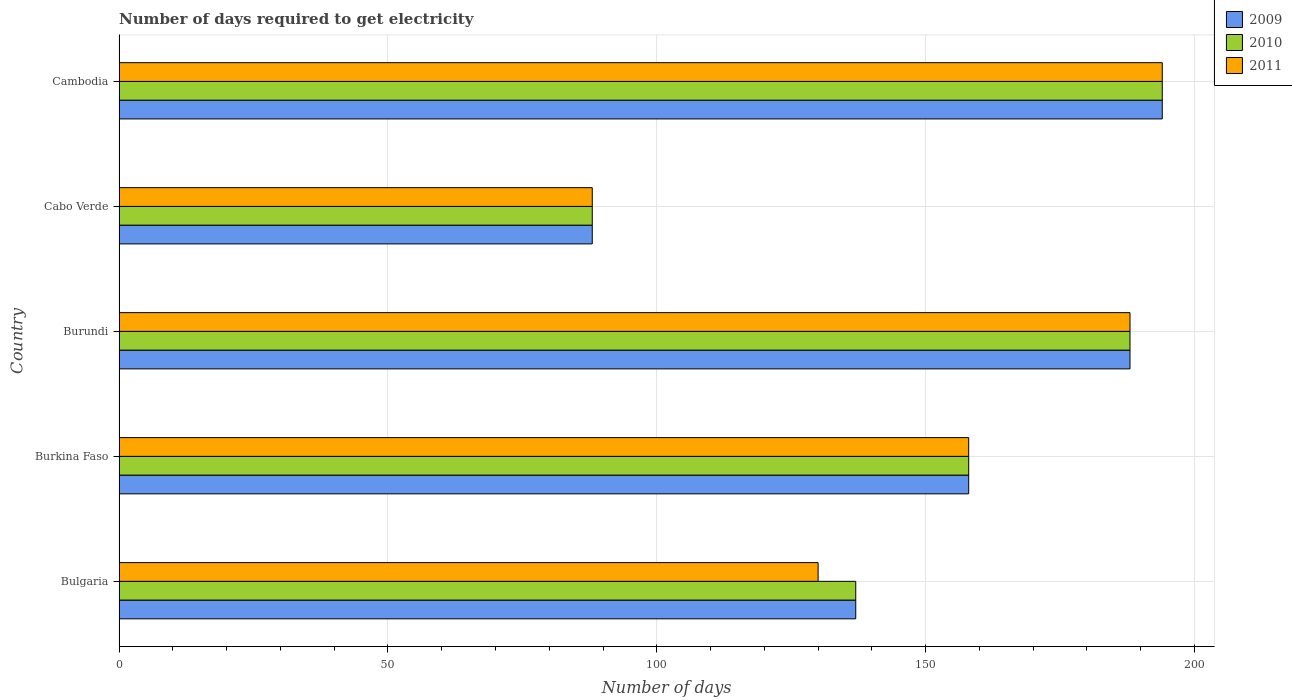How many different coloured bars are there?
Offer a terse response. 3. Are the number of bars per tick equal to the number of legend labels?
Offer a terse response. Yes. Are the number of bars on each tick of the Y-axis equal?
Provide a short and direct response. Yes. How many bars are there on the 3rd tick from the top?
Offer a very short reply. 3. How many bars are there on the 2nd tick from the bottom?
Provide a succinct answer. 3. What is the label of the 3rd group of bars from the top?
Give a very brief answer. Burundi. In how many cases, is the number of bars for a given country not equal to the number of legend labels?
Offer a terse response. 0. What is the number of days required to get electricity in in 2010 in Burkina Faso?
Provide a short and direct response. 158. Across all countries, what is the maximum number of days required to get electricity in in 2011?
Ensure brevity in your answer.  194. Across all countries, what is the minimum number of days required to get electricity in in 2011?
Keep it short and to the point. 88. In which country was the number of days required to get electricity in in 2011 maximum?
Offer a terse response. Cambodia. In which country was the number of days required to get electricity in in 2011 minimum?
Your answer should be compact. Cabo Verde. What is the total number of days required to get electricity in in 2009 in the graph?
Provide a short and direct response. 765. What is the average number of days required to get electricity in in 2010 per country?
Your response must be concise. 153. What is the difference between the number of days required to get electricity in in 2009 and number of days required to get electricity in in 2010 in Bulgaria?
Provide a short and direct response. 0. What is the ratio of the number of days required to get electricity in in 2010 in Burundi to that in Cabo Verde?
Ensure brevity in your answer.  2.14. What is the difference between the highest and the lowest number of days required to get electricity in in 2010?
Offer a very short reply. 106. In how many countries, is the number of days required to get electricity in in 2011 greater than the average number of days required to get electricity in in 2011 taken over all countries?
Your answer should be compact. 3. Is the sum of the number of days required to get electricity in in 2009 in Burkina Faso and Burundi greater than the maximum number of days required to get electricity in in 2011 across all countries?
Your answer should be compact. Yes. Is it the case that in every country, the sum of the number of days required to get electricity in in 2009 and number of days required to get electricity in in 2011 is greater than the number of days required to get electricity in in 2010?
Your answer should be compact. Yes. How many countries are there in the graph?
Make the answer very short. 5. Does the graph contain grids?
Ensure brevity in your answer.  Yes. Where does the legend appear in the graph?
Your answer should be very brief. Top right. How many legend labels are there?
Provide a succinct answer. 3. How are the legend labels stacked?
Ensure brevity in your answer.  Vertical. What is the title of the graph?
Your answer should be compact. Number of days required to get electricity. Does "2009" appear as one of the legend labels in the graph?
Your answer should be very brief. Yes. What is the label or title of the X-axis?
Offer a terse response. Number of days. What is the label or title of the Y-axis?
Give a very brief answer. Country. What is the Number of days of 2009 in Bulgaria?
Give a very brief answer. 137. What is the Number of days of 2010 in Bulgaria?
Provide a succinct answer. 137. What is the Number of days of 2011 in Bulgaria?
Provide a succinct answer. 130. What is the Number of days in 2009 in Burkina Faso?
Make the answer very short. 158. What is the Number of days in 2010 in Burkina Faso?
Your answer should be compact. 158. What is the Number of days in 2011 in Burkina Faso?
Keep it short and to the point. 158. What is the Number of days of 2009 in Burundi?
Provide a short and direct response. 188. What is the Number of days of 2010 in Burundi?
Offer a terse response. 188. What is the Number of days of 2011 in Burundi?
Your answer should be compact. 188. What is the Number of days of 2009 in Cabo Verde?
Your answer should be very brief. 88. What is the Number of days of 2010 in Cabo Verde?
Provide a succinct answer. 88. What is the Number of days in 2011 in Cabo Verde?
Your answer should be compact. 88. What is the Number of days of 2009 in Cambodia?
Your answer should be compact. 194. What is the Number of days in 2010 in Cambodia?
Keep it short and to the point. 194. What is the Number of days in 2011 in Cambodia?
Ensure brevity in your answer.  194. Across all countries, what is the maximum Number of days of 2009?
Make the answer very short. 194. Across all countries, what is the maximum Number of days in 2010?
Your response must be concise. 194. Across all countries, what is the maximum Number of days of 2011?
Offer a terse response. 194. What is the total Number of days of 2009 in the graph?
Your answer should be compact. 765. What is the total Number of days of 2010 in the graph?
Keep it short and to the point. 765. What is the total Number of days of 2011 in the graph?
Ensure brevity in your answer.  758. What is the difference between the Number of days of 2009 in Bulgaria and that in Burundi?
Provide a short and direct response. -51. What is the difference between the Number of days of 2010 in Bulgaria and that in Burundi?
Ensure brevity in your answer.  -51. What is the difference between the Number of days of 2011 in Bulgaria and that in Burundi?
Provide a short and direct response. -58. What is the difference between the Number of days of 2009 in Bulgaria and that in Cabo Verde?
Your answer should be compact. 49. What is the difference between the Number of days of 2009 in Bulgaria and that in Cambodia?
Make the answer very short. -57. What is the difference between the Number of days in 2010 in Bulgaria and that in Cambodia?
Provide a short and direct response. -57. What is the difference between the Number of days of 2011 in Bulgaria and that in Cambodia?
Make the answer very short. -64. What is the difference between the Number of days of 2009 in Burkina Faso and that in Burundi?
Offer a terse response. -30. What is the difference between the Number of days of 2011 in Burkina Faso and that in Cabo Verde?
Give a very brief answer. 70. What is the difference between the Number of days of 2009 in Burkina Faso and that in Cambodia?
Provide a succinct answer. -36. What is the difference between the Number of days in 2010 in Burkina Faso and that in Cambodia?
Give a very brief answer. -36. What is the difference between the Number of days in 2011 in Burkina Faso and that in Cambodia?
Your answer should be very brief. -36. What is the difference between the Number of days in 2010 in Burundi and that in Cabo Verde?
Ensure brevity in your answer.  100. What is the difference between the Number of days in 2010 in Burundi and that in Cambodia?
Your answer should be compact. -6. What is the difference between the Number of days in 2011 in Burundi and that in Cambodia?
Provide a short and direct response. -6. What is the difference between the Number of days of 2009 in Cabo Verde and that in Cambodia?
Your answer should be very brief. -106. What is the difference between the Number of days of 2010 in Cabo Verde and that in Cambodia?
Your answer should be compact. -106. What is the difference between the Number of days of 2011 in Cabo Verde and that in Cambodia?
Keep it short and to the point. -106. What is the difference between the Number of days in 2009 in Bulgaria and the Number of days in 2010 in Burundi?
Keep it short and to the point. -51. What is the difference between the Number of days of 2009 in Bulgaria and the Number of days of 2011 in Burundi?
Ensure brevity in your answer.  -51. What is the difference between the Number of days in 2010 in Bulgaria and the Number of days in 2011 in Burundi?
Your answer should be very brief. -51. What is the difference between the Number of days in 2009 in Bulgaria and the Number of days in 2010 in Cabo Verde?
Your answer should be compact. 49. What is the difference between the Number of days of 2010 in Bulgaria and the Number of days of 2011 in Cabo Verde?
Provide a succinct answer. 49. What is the difference between the Number of days in 2009 in Bulgaria and the Number of days in 2010 in Cambodia?
Offer a terse response. -57. What is the difference between the Number of days in 2009 in Bulgaria and the Number of days in 2011 in Cambodia?
Offer a terse response. -57. What is the difference between the Number of days of 2010 in Bulgaria and the Number of days of 2011 in Cambodia?
Make the answer very short. -57. What is the difference between the Number of days in 2009 in Burkina Faso and the Number of days in 2011 in Burundi?
Your answer should be very brief. -30. What is the difference between the Number of days in 2009 in Burkina Faso and the Number of days in 2011 in Cabo Verde?
Provide a short and direct response. 70. What is the difference between the Number of days of 2009 in Burkina Faso and the Number of days of 2010 in Cambodia?
Give a very brief answer. -36. What is the difference between the Number of days of 2009 in Burkina Faso and the Number of days of 2011 in Cambodia?
Your answer should be very brief. -36. What is the difference between the Number of days of 2010 in Burkina Faso and the Number of days of 2011 in Cambodia?
Keep it short and to the point. -36. What is the difference between the Number of days in 2009 in Burundi and the Number of days in 2010 in Cabo Verde?
Provide a short and direct response. 100. What is the difference between the Number of days of 2009 in Burundi and the Number of days of 2011 in Cabo Verde?
Give a very brief answer. 100. What is the difference between the Number of days of 2010 in Burundi and the Number of days of 2011 in Cabo Verde?
Give a very brief answer. 100. What is the difference between the Number of days of 2009 in Burundi and the Number of days of 2010 in Cambodia?
Ensure brevity in your answer.  -6. What is the difference between the Number of days of 2009 in Burundi and the Number of days of 2011 in Cambodia?
Provide a short and direct response. -6. What is the difference between the Number of days in 2009 in Cabo Verde and the Number of days in 2010 in Cambodia?
Your answer should be compact. -106. What is the difference between the Number of days of 2009 in Cabo Verde and the Number of days of 2011 in Cambodia?
Make the answer very short. -106. What is the difference between the Number of days of 2010 in Cabo Verde and the Number of days of 2011 in Cambodia?
Give a very brief answer. -106. What is the average Number of days of 2009 per country?
Your answer should be very brief. 153. What is the average Number of days of 2010 per country?
Make the answer very short. 153. What is the average Number of days of 2011 per country?
Provide a succinct answer. 151.6. What is the difference between the Number of days of 2009 and Number of days of 2010 in Bulgaria?
Offer a terse response. 0. What is the difference between the Number of days of 2010 and Number of days of 2011 in Bulgaria?
Your answer should be compact. 7. What is the difference between the Number of days of 2009 and Number of days of 2011 in Burkina Faso?
Keep it short and to the point. 0. What is the difference between the Number of days of 2010 and Number of days of 2011 in Burkina Faso?
Your answer should be compact. 0. What is the difference between the Number of days in 2009 and Number of days in 2011 in Burundi?
Your answer should be very brief. 0. What is the difference between the Number of days in 2009 and Number of days in 2010 in Cabo Verde?
Offer a very short reply. 0. What is the difference between the Number of days in 2010 and Number of days in 2011 in Cabo Verde?
Provide a succinct answer. 0. What is the difference between the Number of days of 2009 and Number of days of 2010 in Cambodia?
Give a very brief answer. 0. What is the difference between the Number of days in 2009 and Number of days in 2011 in Cambodia?
Make the answer very short. 0. What is the ratio of the Number of days in 2009 in Bulgaria to that in Burkina Faso?
Keep it short and to the point. 0.87. What is the ratio of the Number of days of 2010 in Bulgaria to that in Burkina Faso?
Make the answer very short. 0.87. What is the ratio of the Number of days of 2011 in Bulgaria to that in Burkina Faso?
Make the answer very short. 0.82. What is the ratio of the Number of days of 2009 in Bulgaria to that in Burundi?
Offer a very short reply. 0.73. What is the ratio of the Number of days of 2010 in Bulgaria to that in Burundi?
Your answer should be compact. 0.73. What is the ratio of the Number of days of 2011 in Bulgaria to that in Burundi?
Offer a very short reply. 0.69. What is the ratio of the Number of days of 2009 in Bulgaria to that in Cabo Verde?
Give a very brief answer. 1.56. What is the ratio of the Number of days in 2010 in Bulgaria to that in Cabo Verde?
Ensure brevity in your answer.  1.56. What is the ratio of the Number of days in 2011 in Bulgaria to that in Cabo Verde?
Your response must be concise. 1.48. What is the ratio of the Number of days in 2009 in Bulgaria to that in Cambodia?
Ensure brevity in your answer.  0.71. What is the ratio of the Number of days of 2010 in Bulgaria to that in Cambodia?
Your answer should be very brief. 0.71. What is the ratio of the Number of days in 2011 in Bulgaria to that in Cambodia?
Make the answer very short. 0.67. What is the ratio of the Number of days of 2009 in Burkina Faso to that in Burundi?
Provide a short and direct response. 0.84. What is the ratio of the Number of days in 2010 in Burkina Faso to that in Burundi?
Offer a very short reply. 0.84. What is the ratio of the Number of days in 2011 in Burkina Faso to that in Burundi?
Make the answer very short. 0.84. What is the ratio of the Number of days in 2009 in Burkina Faso to that in Cabo Verde?
Give a very brief answer. 1.8. What is the ratio of the Number of days in 2010 in Burkina Faso to that in Cabo Verde?
Ensure brevity in your answer.  1.8. What is the ratio of the Number of days of 2011 in Burkina Faso to that in Cabo Verde?
Keep it short and to the point. 1.8. What is the ratio of the Number of days of 2009 in Burkina Faso to that in Cambodia?
Offer a terse response. 0.81. What is the ratio of the Number of days of 2010 in Burkina Faso to that in Cambodia?
Make the answer very short. 0.81. What is the ratio of the Number of days of 2011 in Burkina Faso to that in Cambodia?
Give a very brief answer. 0.81. What is the ratio of the Number of days in 2009 in Burundi to that in Cabo Verde?
Offer a terse response. 2.14. What is the ratio of the Number of days of 2010 in Burundi to that in Cabo Verde?
Your answer should be compact. 2.14. What is the ratio of the Number of days of 2011 in Burundi to that in Cabo Verde?
Give a very brief answer. 2.14. What is the ratio of the Number of days in 2009 in Burundi to that in Cambodia?
Your response must be concise. 0.97. What is the ratio of the Number of days in 2010 in Burundi to that in Cambodia?
Offer a very short reply. 0.97. What is the ratio of the Number of days of 2011 in Burundi to that in Cambodia?
Your answer should be very brief. 0.97. What is the ratio of the Number of days in 2009 in Cabo Verde to that in Cambodia?
Make the answer very short. 0.45. What is the ratio of the Number of days of 2010 in Cabo Verde to that in Cambodia?
Keep it short and to the point. 0.45. What is the ratio of the Number of days of 2011 in Cabo Verde to that in Cambodia?
Offer a very short reply. 0.45. What is the difference between the highest and the lowest Number of days in 2009?
Provide a succinct answer. 106. What is the difference between the highest and the lowest Number of days in 2010?
Offer a terse response. 106. What is the difference between the highest and the lowest Number of days of 2011?
Offer a very short reply. 106. 